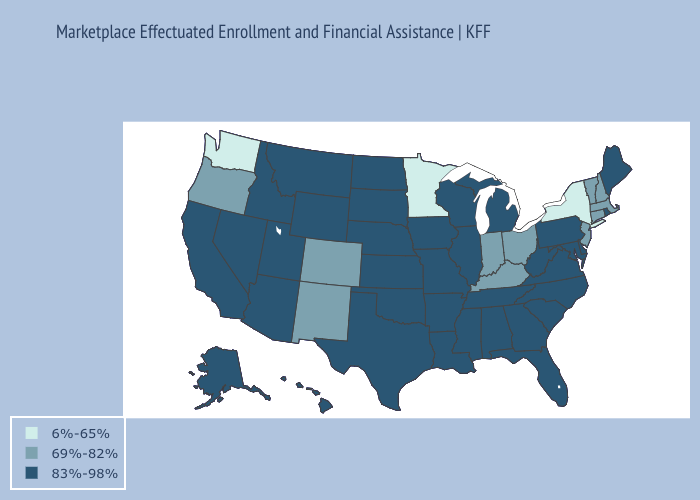Does Minnesota have the highest value in the MidWest?
Answer briefly. No. Does Connecticut have the lowest value in the USA?
Give a very brief answer. No. What is the value of Florida?
Be succinct. 83%-98%. Name the states that have a value in the range 6%-65%?
Quick response, please. Minnesota, New York, Washington. Which states have the lowest value in the USA?
Quick response, please. Minnesota, New York, Washington. Among the states that border New Jersey , does Pennsylvania have the lowest value?
Be succinct. No. What is the lowest value in states that border Kentucky?
Concise answer only. 69%-82%. Does New Mexico have the same value as Hawaii?
Quick response, please. No. Which states have the lowest value in the Northeast?
Keep it brief. New York. Name the states that have a value in the range 83%-98%?
Be succinct. Alabama, Alaska, Arizona, Arkansas, California, Delaware, Florida, Georgia, Hawaii, Idaho, Illinois, Iowa, Kansas, Louisiana, Maine, Maryland, Michigan, Mississippi, Missouri, Montana, Nebraska, Nevada, North Carolina, North Dakota, Oklahoma, Pennsylvania, Rhode Island, South Carolina, South Dakota, Tennessee, Texas, Utah, Virginia, West Virginia, Wisconsin, Wyoming. Name the states that have a value in the range 6%-65%?
Keep it brief. Minnesota, New York, Washington. Does Hawaii have the highest value in the West?
Give a very brief answer. Yes. Does Virginia have the lowest value in the USA?
Concise answer only. No. What is the value of Utah?
Concise answer only. 83%-98%. 